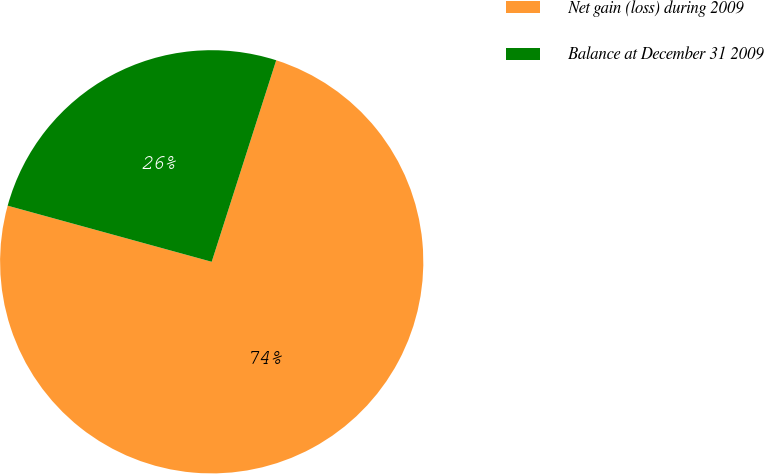Convert chart to OTSL. <chart><loc_0><loc_0><loc_500><loc_500><pie_chart><fcel>Net gain (loss) during 2009<fcel>Balance at December 31 2009<nl><fcel>74.34%<fcel>25.66%<nl></chart> 